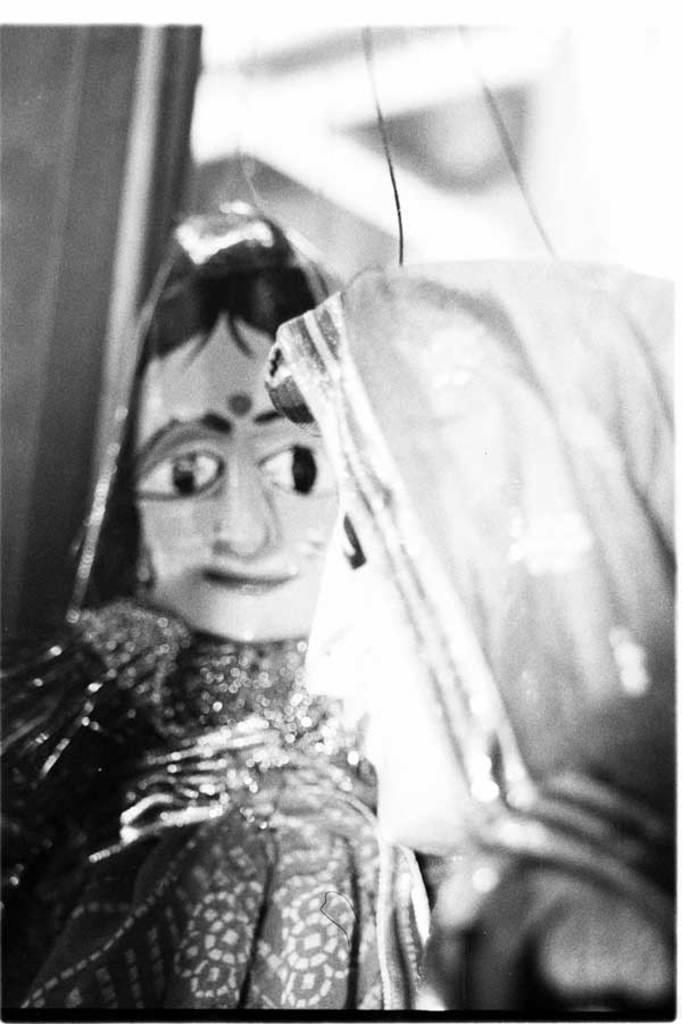How would you summarize this image in a sentence or two? In this image we can see the puppetry and there is the blur background. 